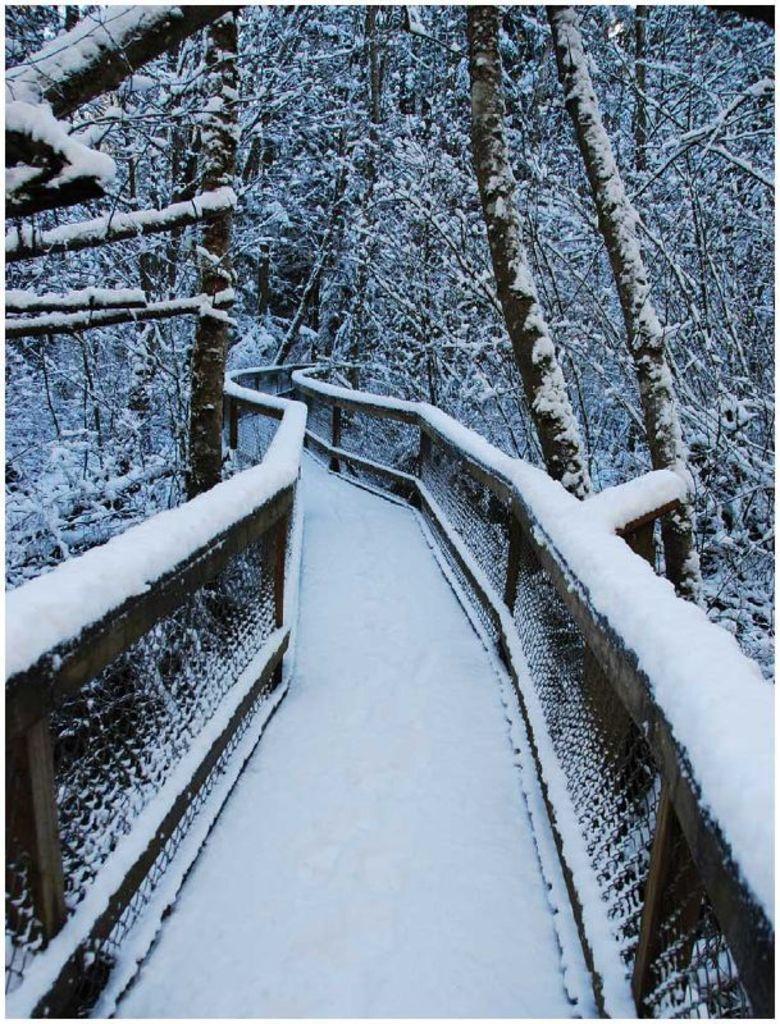Please provide a concise description of this image. In the picture we can see a bridge with a railing and besides, we can see trees and on the bridge and trees we can see a snowfall. 